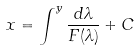Convert formula to latex. <formula><loc_0><loc_0><loc_500><loc_500>x = \int ^ { y } \frac { d \lambda } { F ( \lambda ) } + C</formula> 